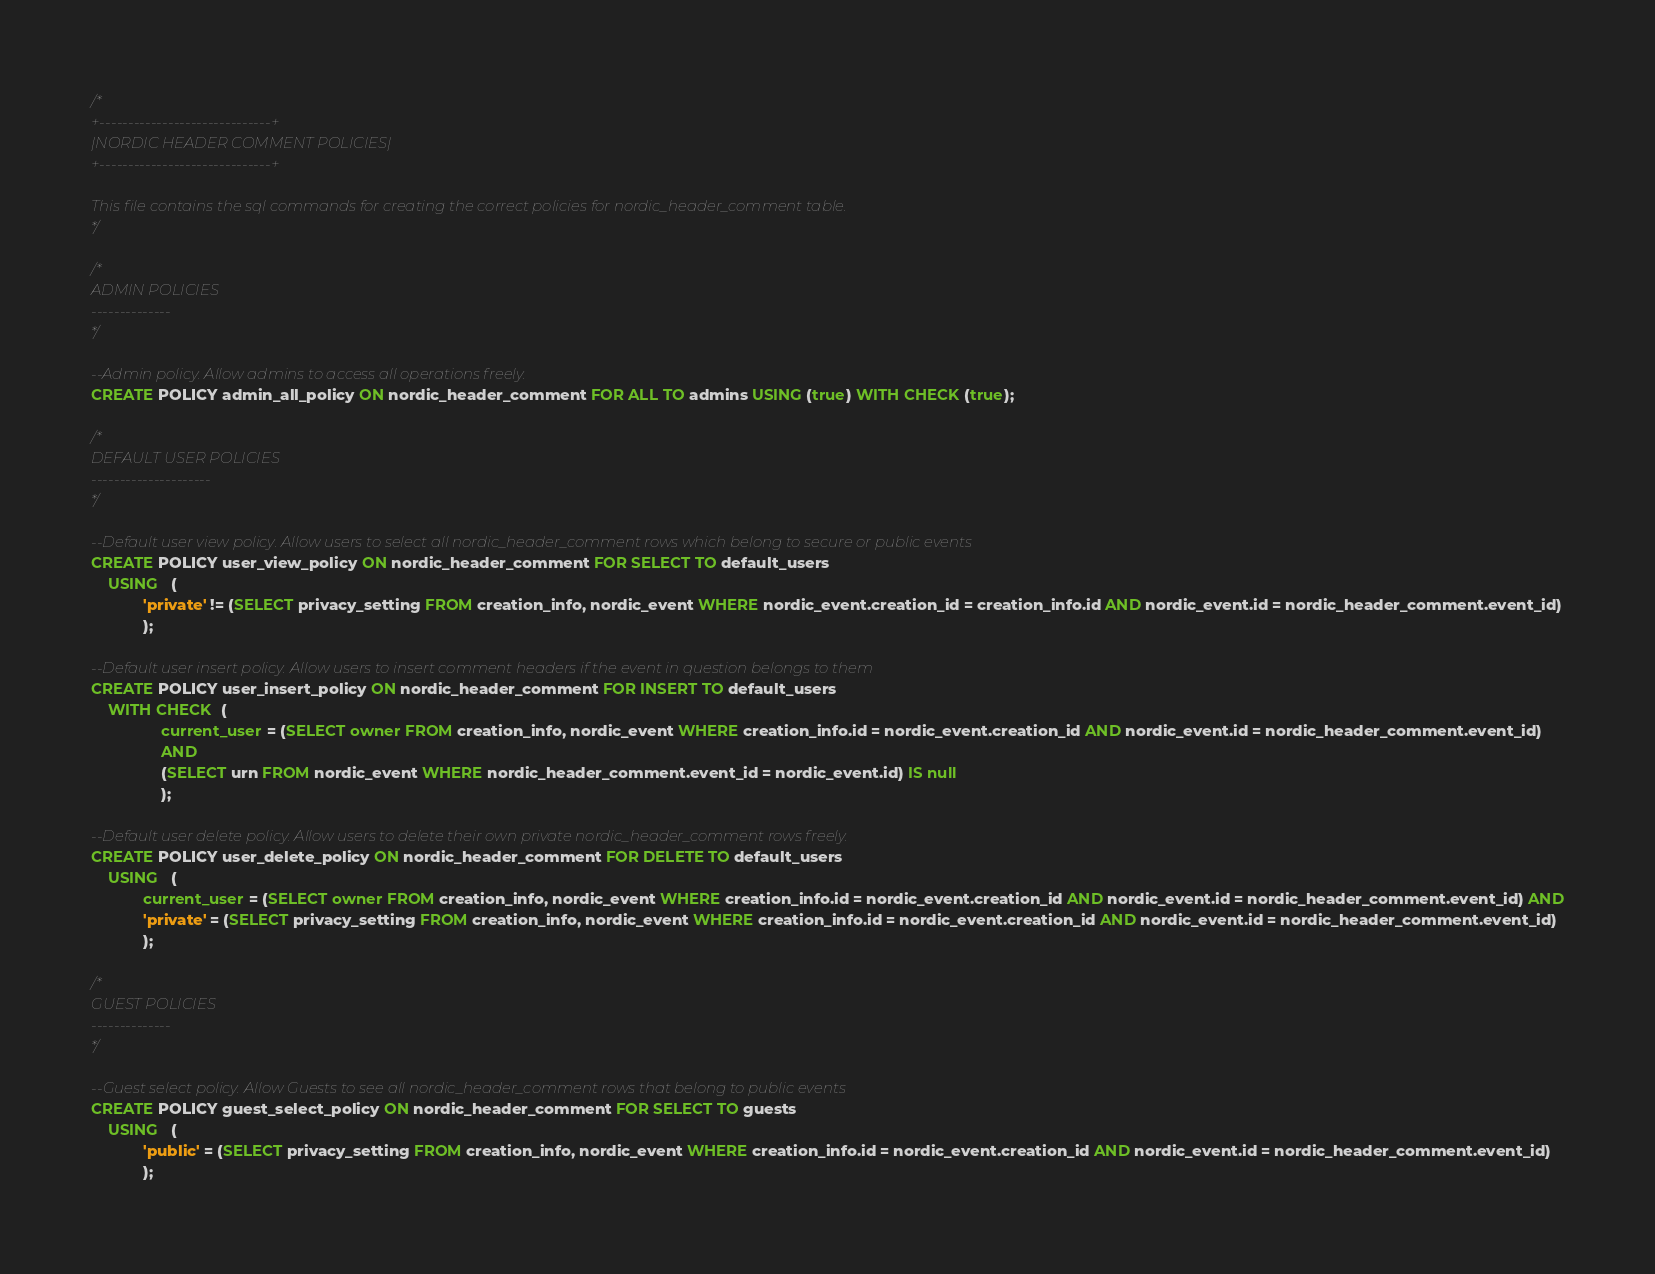Convert code to text. <code><loc_0><loc_0><loc_500><loc_500><_SQL_>/*
+------------------------------+
|NORDIC HEADER COMMENT POLICIES|
+------------------------------+

This file contains the sql commands for creating the correct policies for nordic_header_comment table.
*/

/*
ADMIN POLICIES
--------------
*/

--Admin policy. Allow admins to access all operations freely.
CREATE POLICY admin_all_policy ON nordic_header_comment FOR ALL TO admins USING (true) WITH CHECK (true);

/*
DEFAULT USER POLICIES
---------------------
*/

--Default user view policy. Allow users to select all nordic_header_comment rows which belong to secure or public events
CREATE POLICY user_view_policy ON nordic_header_comment FOR SELECT TO default_users 
    USING   (
            'private' != (SELECT privacy_setting FROM creation_info, nordic_event WHERE nordic_event.creation_id = creation_info.id AND nordic_event.id = nordic_header_comment.event_id)
            );

--Default user insert policy. Allow users to insert comment headers if the event in question belongs to them
CREATE POLICY user_insert_policy ON nordic_header_comment FOR INSERT TO default_users 
    WITH CHECK  (
                current_user = (SELECT owner FROM creation_info, nordic_event WHERE creation_info.id = nordic_event.creation_id AND nordic_event.id = nordic_header_comment.event_id)
                AND
                (SELECT urn FROM nordic_event WHERE nordic_header_comment.event_id = nordic_event.id) IS null
                );

--Default user delete policy. Allow users to delete their own private nordic_header_comment rows freely.
CREATE POLICY user_delete_policy ON nordic_header_comment FOR DELETE TO default_users 
    USING   (
            current_user = (SELECT owner FROM creation_info, nordic_event WHERE creation_info.id = nordic_event.creation_id AND nordic_event.id = nordic_header_comment.event_id) AND
            'private' = (SELECT privacy_setting FROM creation_info, nordic_event WHERE creation_info.id = nordic_event.creation_id AND nordic_event.id = nordic_header_comment.event_id)
            );

/*
GUEST POLICIES
--------------
*/

--Guest select policy. Allow Guests to see all nordic_header_comment rows that belong to public events 
CREATE POLICY guest_select_policy ON nordic_header_comment FOR SELECT TO guests
    USING   (
            'public' = (SELECT privacy_setting FROM creation_info, nordic_event WHERE creation_info.id = nordic_event.creation_id AND nordic_event.id = nordic_header_comment.event_id)
            );
</code> 